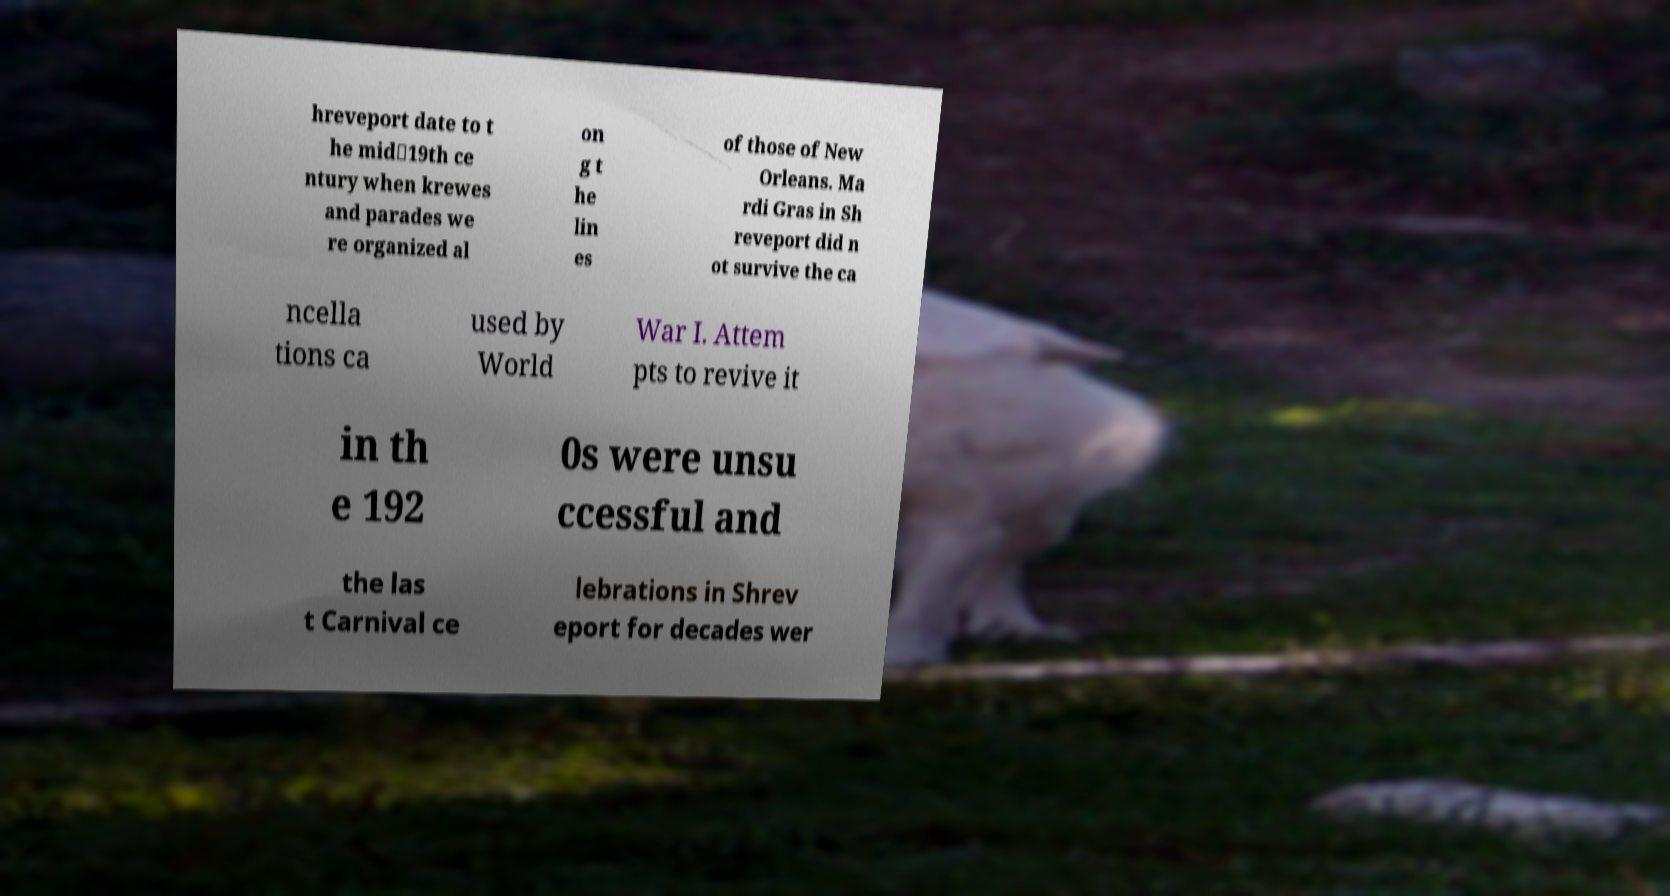Please identify and transcribe the text found in this image. hreveport date to t he mid‑19th ce ntury when krewes and parades we re organized al on g t he lin es of those of New Orleans. Ma rdi Gras in Sh reveport did n ot survive the ca ncella tions ca used by World War I. Attem pts to revive it in th e 192 0s were unsu ccessful and the las t Carnival ce lebrations in Shrev eport for decades wer 